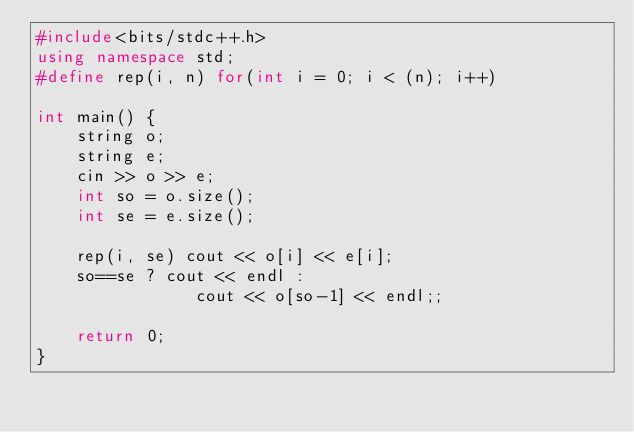<code> <loc_0><loc_0><loc_500><loc_500><_C++_>#include<bits/stdc++.h>
using namespace std;
#define rep(i, n) for(int i = 0; i < (n); i++)

int main() {
    string o;
    string e;
    cin >> o >> e;
    int so = o.size();
    int se = e.size();

    rep(i, se) cout << o[i] << e[i];
    so==se ? cout << endl :
                cout << o[so-1] << endl;;
    
    return 0;
}</code> 